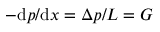Convert formula to latex. <formula><loc_0><loc_0><loc_500><loc_500>- d p / d x = \Delta p / L = G</formula> 